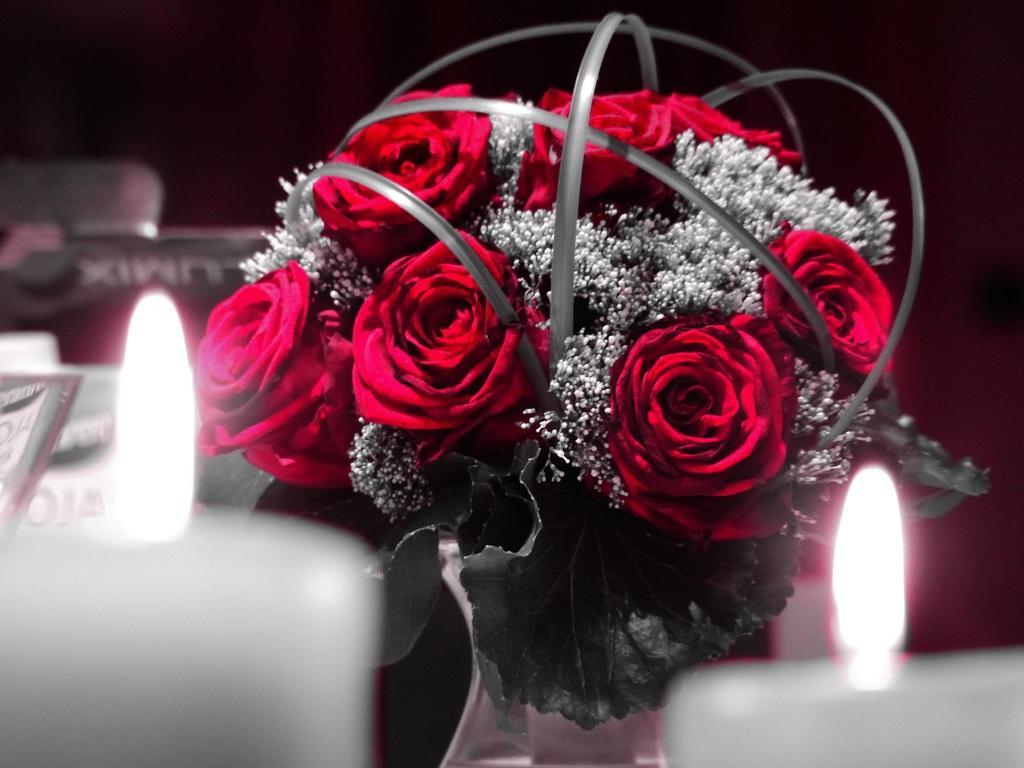How would you summarize this image in a sentence or two? In this image, we can see candles which are light and there is a flower vase and some other objects. 